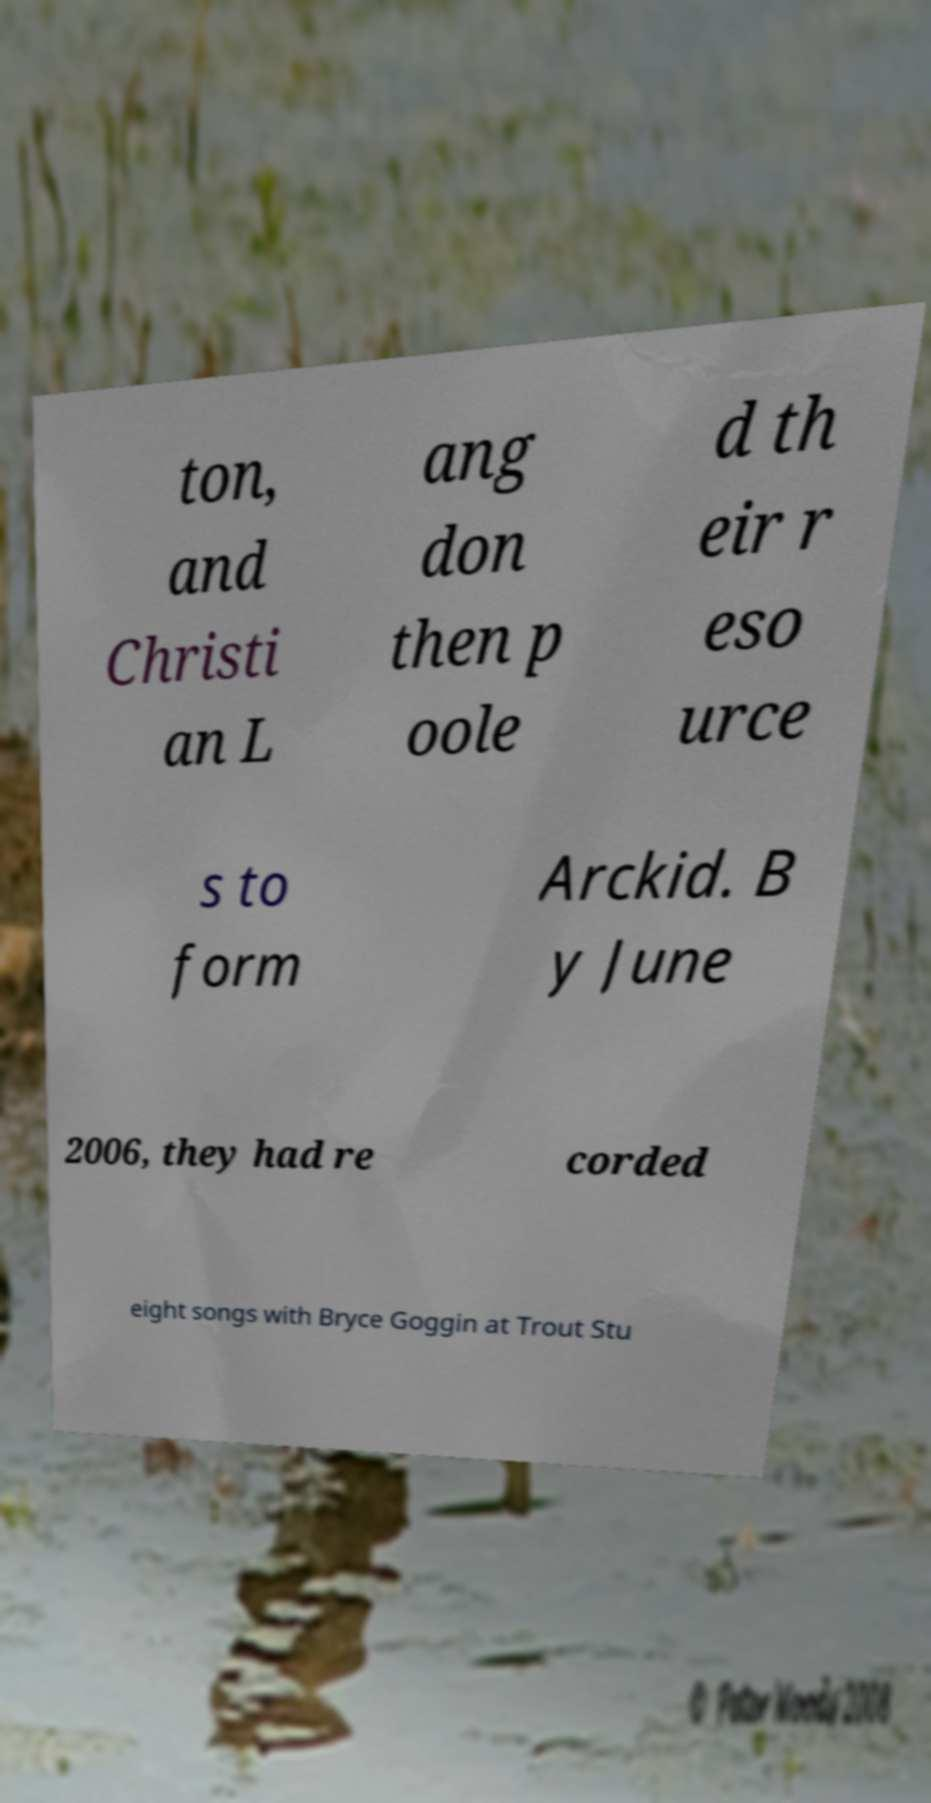For documentation purposes, I need the text within this image transcribed. Could you provide that? ton, and Christi an L ang don then p oole d th eir r eso urce s to form Arckid. B y June 2006, they had re corded eight songs with Bryce Goggin at Trout Stu 